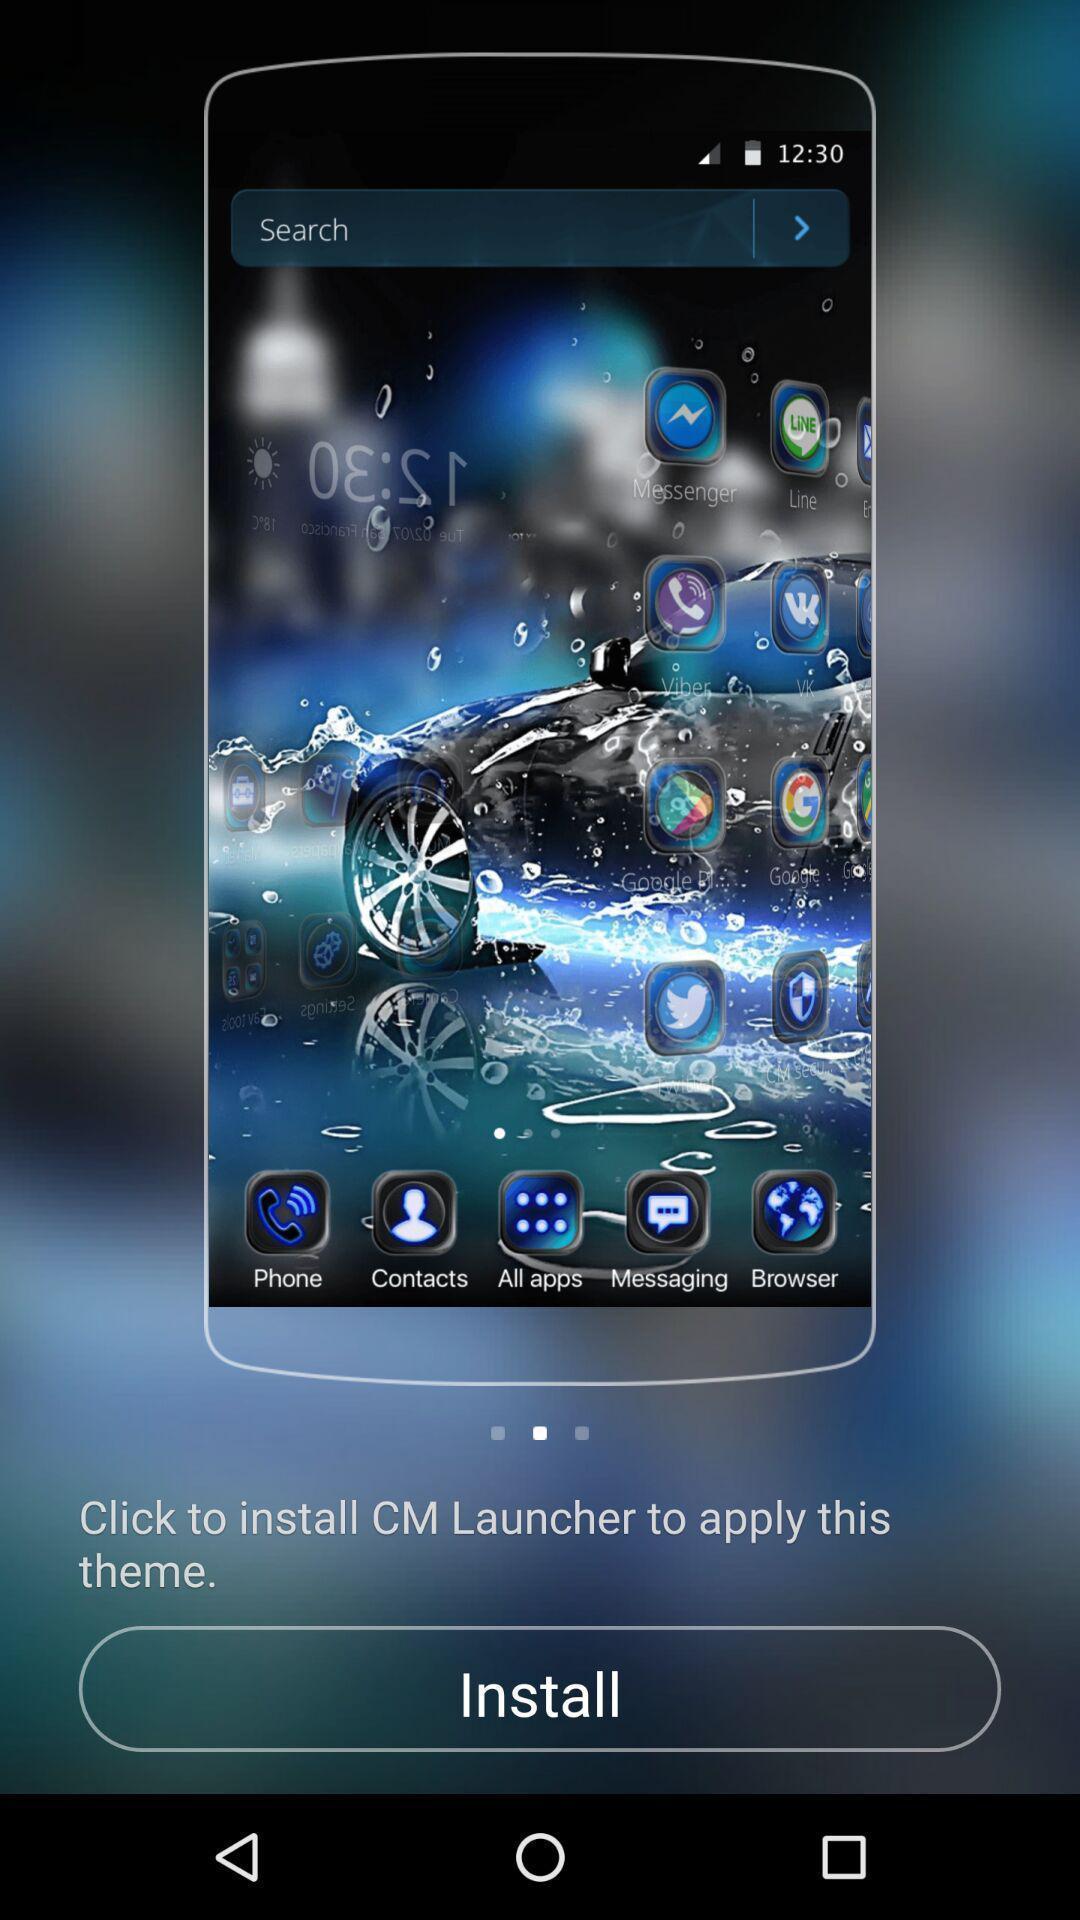What details can you identify in this image? Page showing option to install app. 